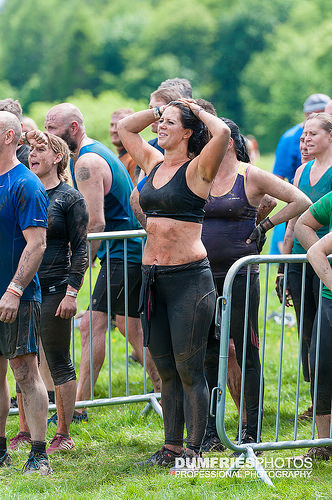<image>
Is the girl in front of the girl? Yes. The girl is positioned in front of the girl, appearing closer to the camera viewpoint. 